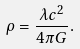Convert formula to latex. <formula><loc_0><loc_0><loc_500><loc_500>\rho = \frac { \lambda c ^ { 2 } } { 4 \pi G } .</formula> 